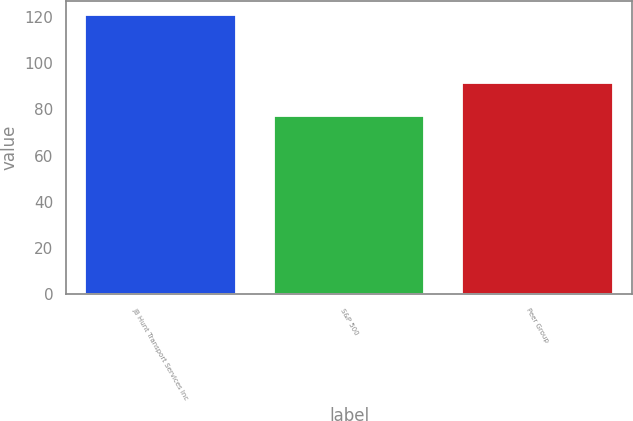Convert chart. <chart><loc_0><loc_0><loc_500><loc_500><bar_chart><fcel>JB Hunt Transport Services Inc<fcel>S&P 500<fcel>Peer Group<nl><fcel>120.85<fcel>76.96<fcel>91.38<nl></chart> 